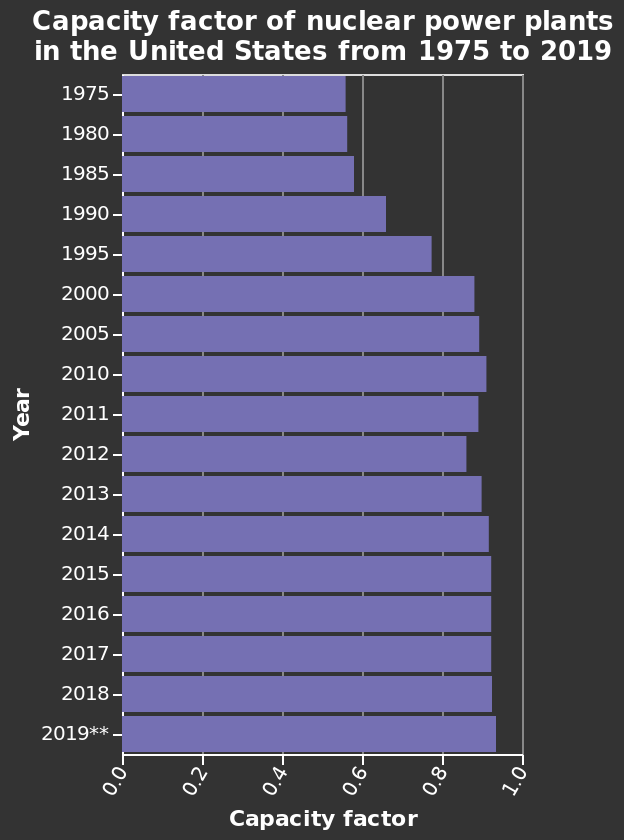<image>
What does the y-axis measure in the bar chart? The y-axis measures the Year, which is categorized from 1975 to 2019. please summary the statistics and relations of the chart The later the year the bigger the capacity factor gets. 